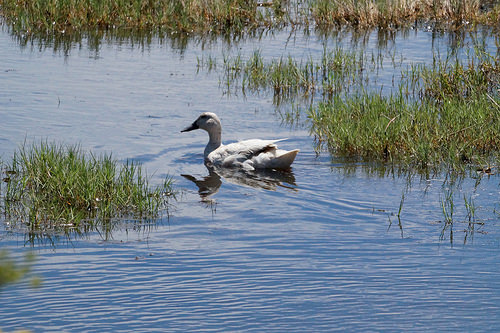<image>
Can you confirm if the bird is in front of the grass? Yes. The bird is positioned in front of the grass, appearing closer to the camera viewpoint. 